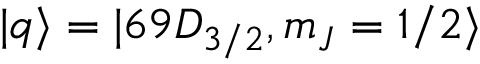Convert formula to latex. <formula><loc_0><loc_0><loc_500><loc_500>| q \rangle = | 6 9 D _ { 3 / 2 } , m _ { J } = 1 / 2 \rangle</formula> 